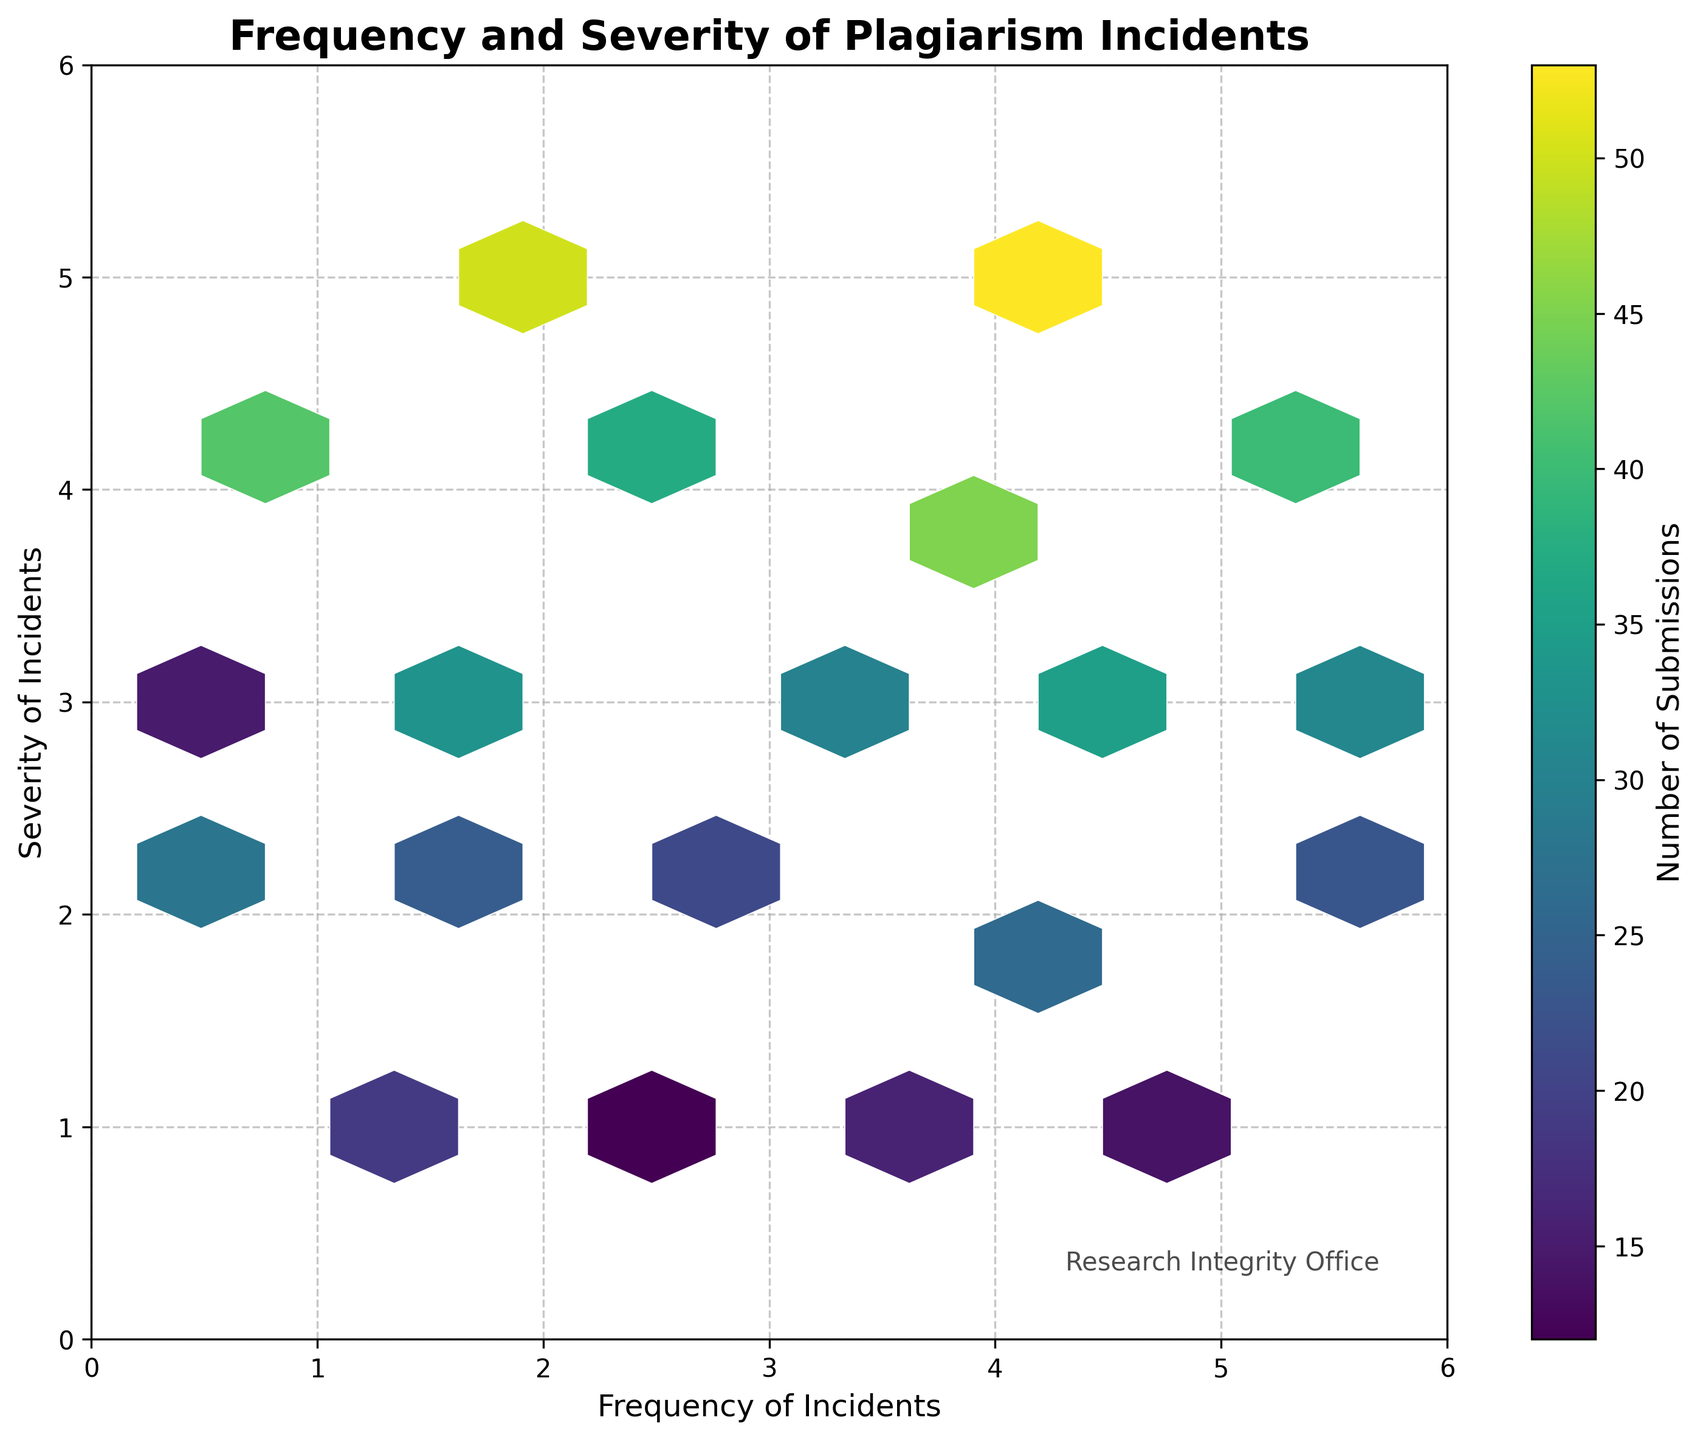What is the title of the plot? The title of the plot is located at the top and is prominently displayed in bold font.
Answer: Frequency and Severity of Plagiarism Incidents What are the axes labeled? The x-axis label is found horizontally along the bottom of the plot, and the y-axis label is found vertically along the left side of the plot.
Answer: Frequency of Incidents (x-axis) and Severity of Incidents (y-axis) What color scheme is used for the hexagons in the plot? The hexagons in the plot use a color scheme that ranges from dark blue to bright yellow, with variations indicating different counts of submissions.
Answer: Viridis color scheme What does the color bar represent in the plot? The color bar is positioned to the side of the plot and provides a gradient of colors corresponding to different numerical values.
Answer: Number of Submissions Which hex cell has the highest count of submissions? Look for the hex cell with the brightest yellow color, as this indicates the highest number of submissions. The exact count can be verified with the color bar.
Answer: Hex cell at (4.4, 5) What is the range of frequencies represented on the x-axis? The x-axis ranges from the smallest to the largest labeled tick marks. The exact values can be verified by examining the axis labels.
Answer: 0 to 6 Which severity level corresponds to the highest single hex cell count, and what is that count? Locate the hex cell with the highest count (brightest yellow) and note the y-coordinate (severity level) and the count.
Answer: Severity level 5, count 53 How does the count of submissions compare between frequency of 1.1 and frequency of 2.0? Identify the colors of the hex cells at (1.1, y) and (2.0, y), then use the color bar to determine and compare the counts.
Answer: Frequency of 1.1 has 19 submissions, Frequency of 2.0 has 50 submissions What is the average count of submissions for hex cells with frequency values greater than 3.0? Identify all hex cells with x-values greater than 3.0, sum their counts, and divide by the number of such hex cells.
Answer: (45 + 26 + 53 + 35 + 40 + 23 + 31) / 7 = 36.14 Where in the plot is the Research Integrity Office signature located? Look for the text labeled "Research Integrity Office" relative to the axes within the plot.
Answer: Bottom-right corner 